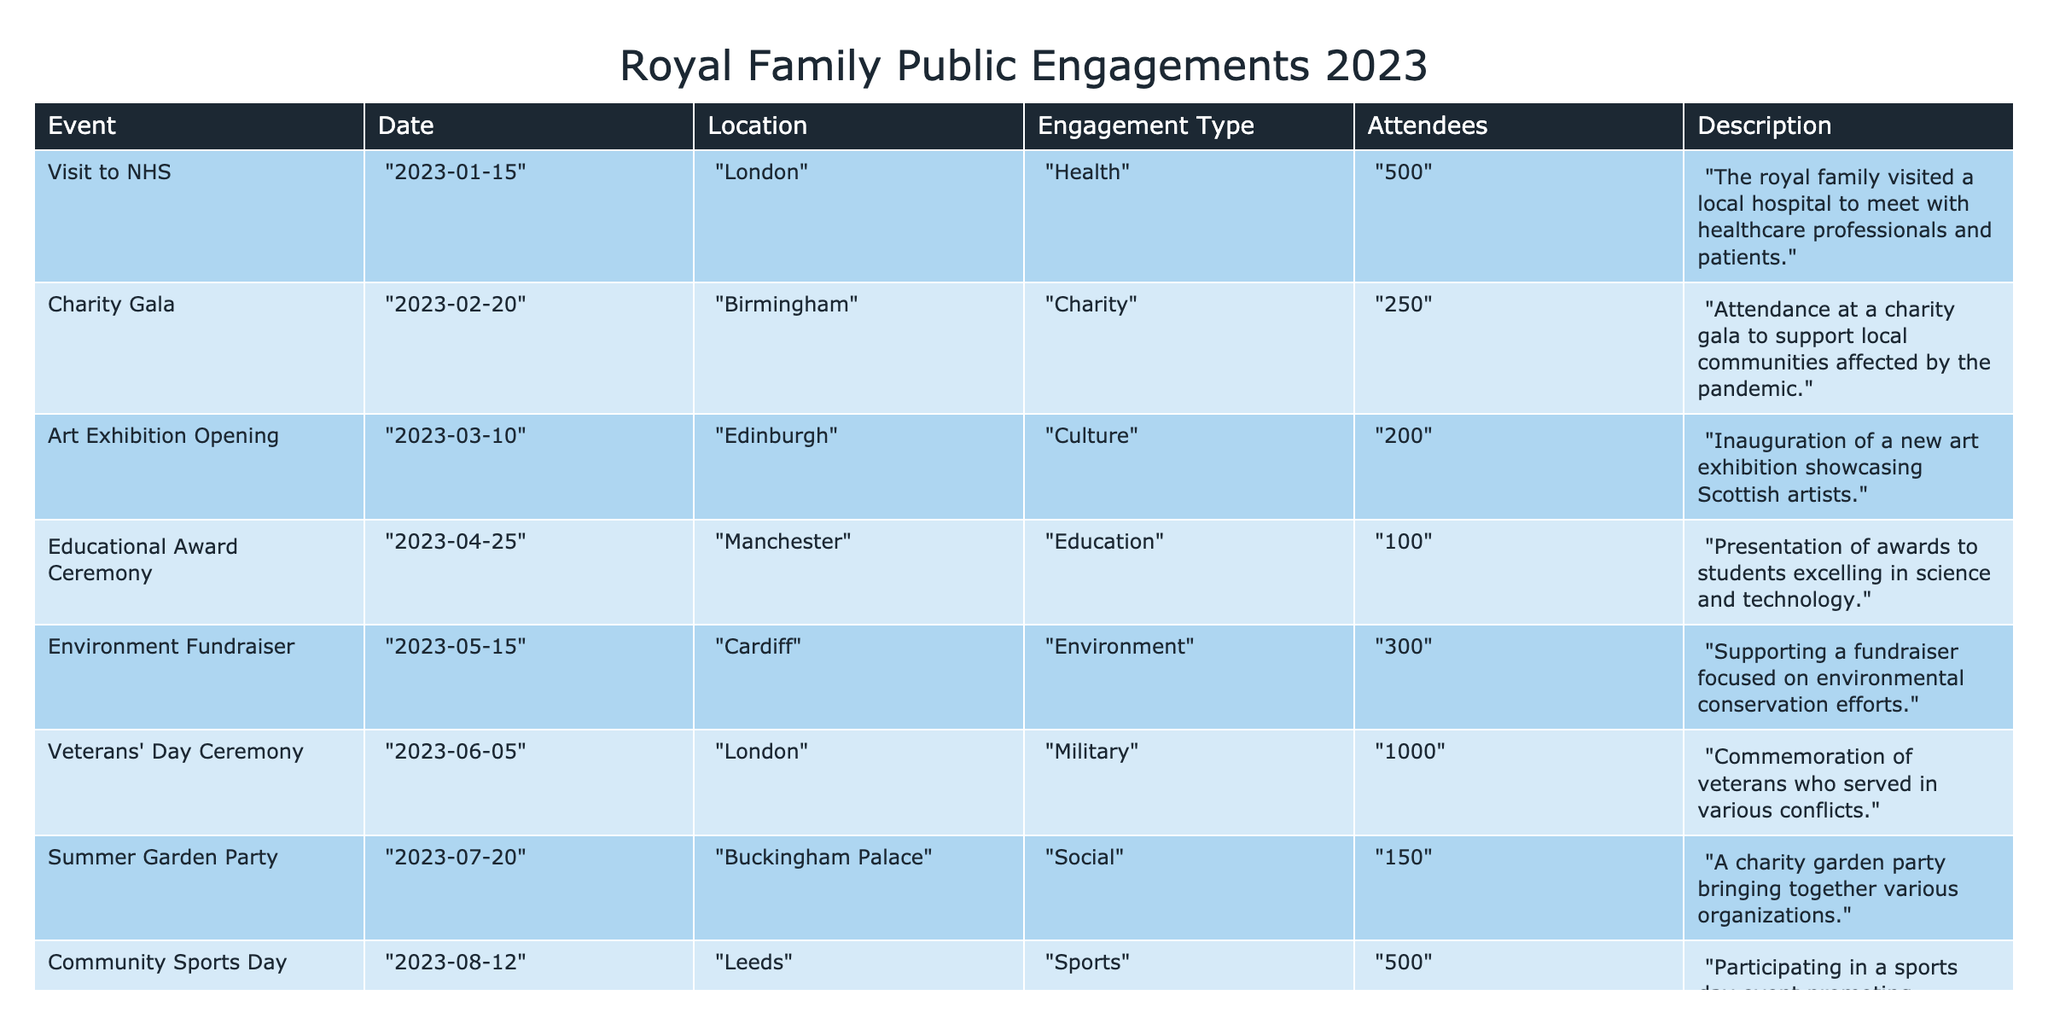What was the date of the Veterans' Day Ceremony? The table lists the date for each event under the "Date" column. The row for the Veterans' Day Ceremony shows it occurred on "2023-06-05."
Answer: 2023-06-05 How many attendees were there at the Charity Gala? By checking the "Attendees" column for the "Charity Gala" event, it states there were "250" attendees.
Answer: 250 What type of event had the highest number of attendees? The highest number of attendees can be determined by comparing the "Attendees" values. The Veterans' Day Ceremony had "1000" attendees, which is the largest number among the events.
Answer: Military What is the average number of attendees across all the events listed? The sum of attendees is (500 + 250 + 200 + 100 + 300 + 1000 + 150 + 500 + 200 + 350 + 1000) = 4050. There are 11 events, so the average is 4050 / 11 = 368.18, which can be rounded to 368.
Answer: 368 Was there an event related to religious activities? Looking through the "Engagement Type" column, the "Christmas Carol Service" is categorized as "Religious," indicating that yes, there was a religious event.
Answer: Yes Which event took place in September 2023? The "Date" column indicates that the event on "2023-09-15" corresponds to the "International Diplomacy Conference."
Answer: International Diplomacy Conference What were the different types of engagement represented in the table? By reviewing the "Engagement Type" column for all entries, the types include Health, Charity, Culture, Education, Environment, Military, Social, Sports, Diplomacy, and Religious.
Answer: Health, Charity, Culture, Education, Environment, Military, Social, Sports, Diplomacy, Religious Which event was focused on environmental conservation, and how many attendees were there? The "Environment Fundraiser" is categorized under "Environment," and it shows that there were "300" attendees.
Answer: Environment Fundraiser, 300 Calculate the difference in the number of attendees between the Christmas Carol Service and the Art Exhibition Opening. The "Christmas Carol Service" had "1000" attendees and the "Art Exhibition Opening" had "200." The difference is 1000 - 200 = 800.
Answer: 800 